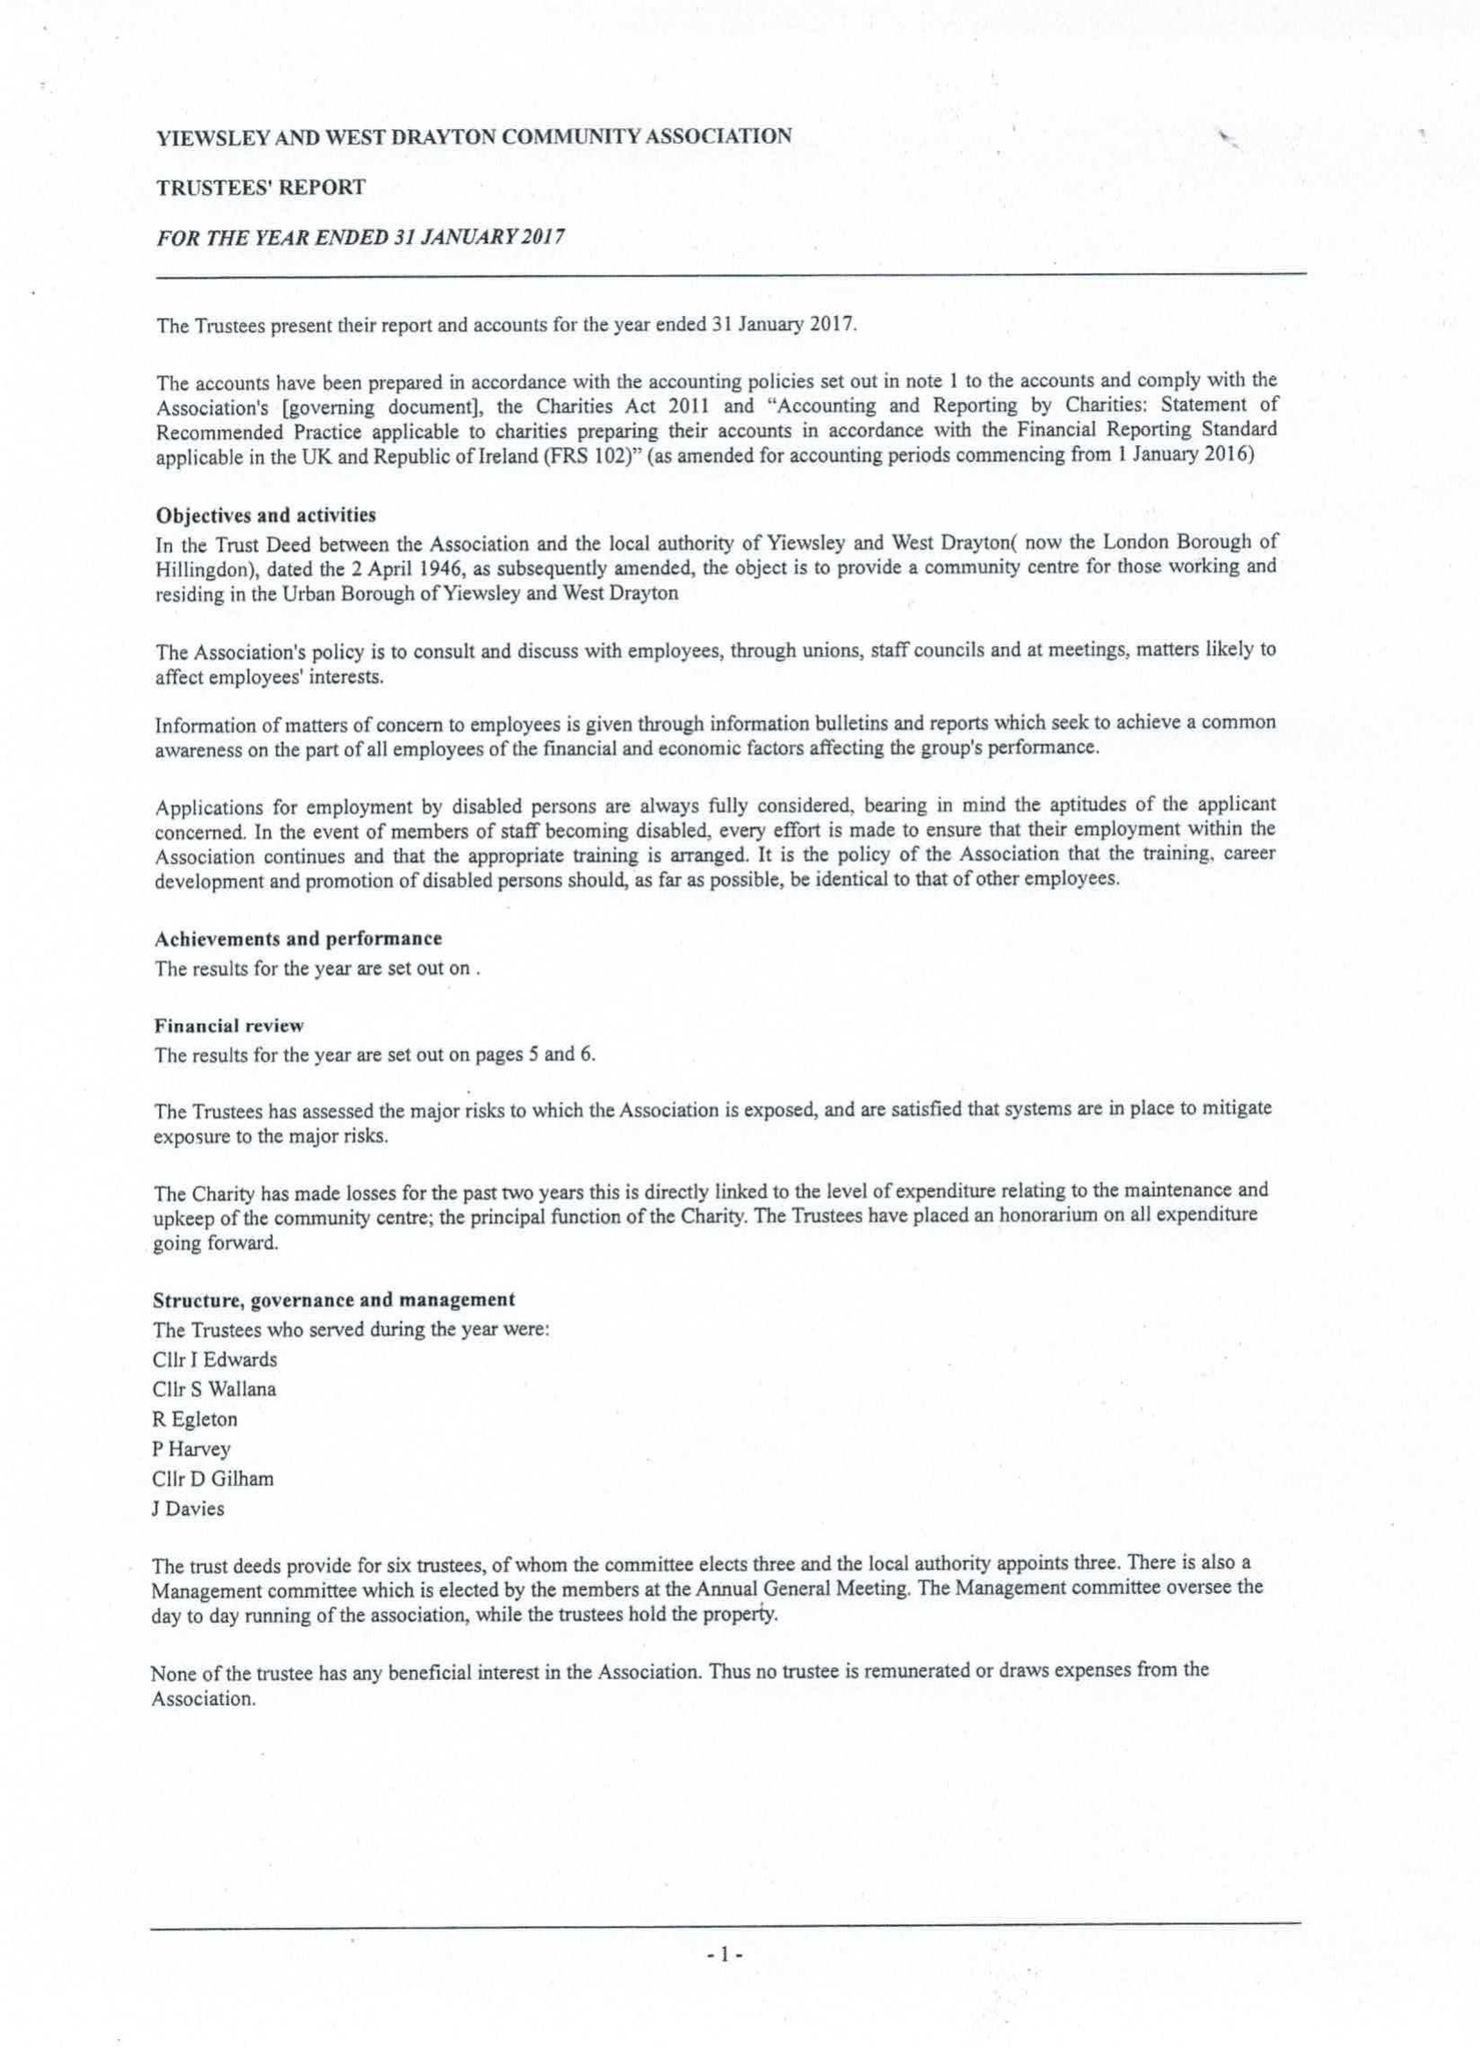What is the value for the income_annually_in_british_pounds?
Answer the question using a single word or phrase. 146241.00 